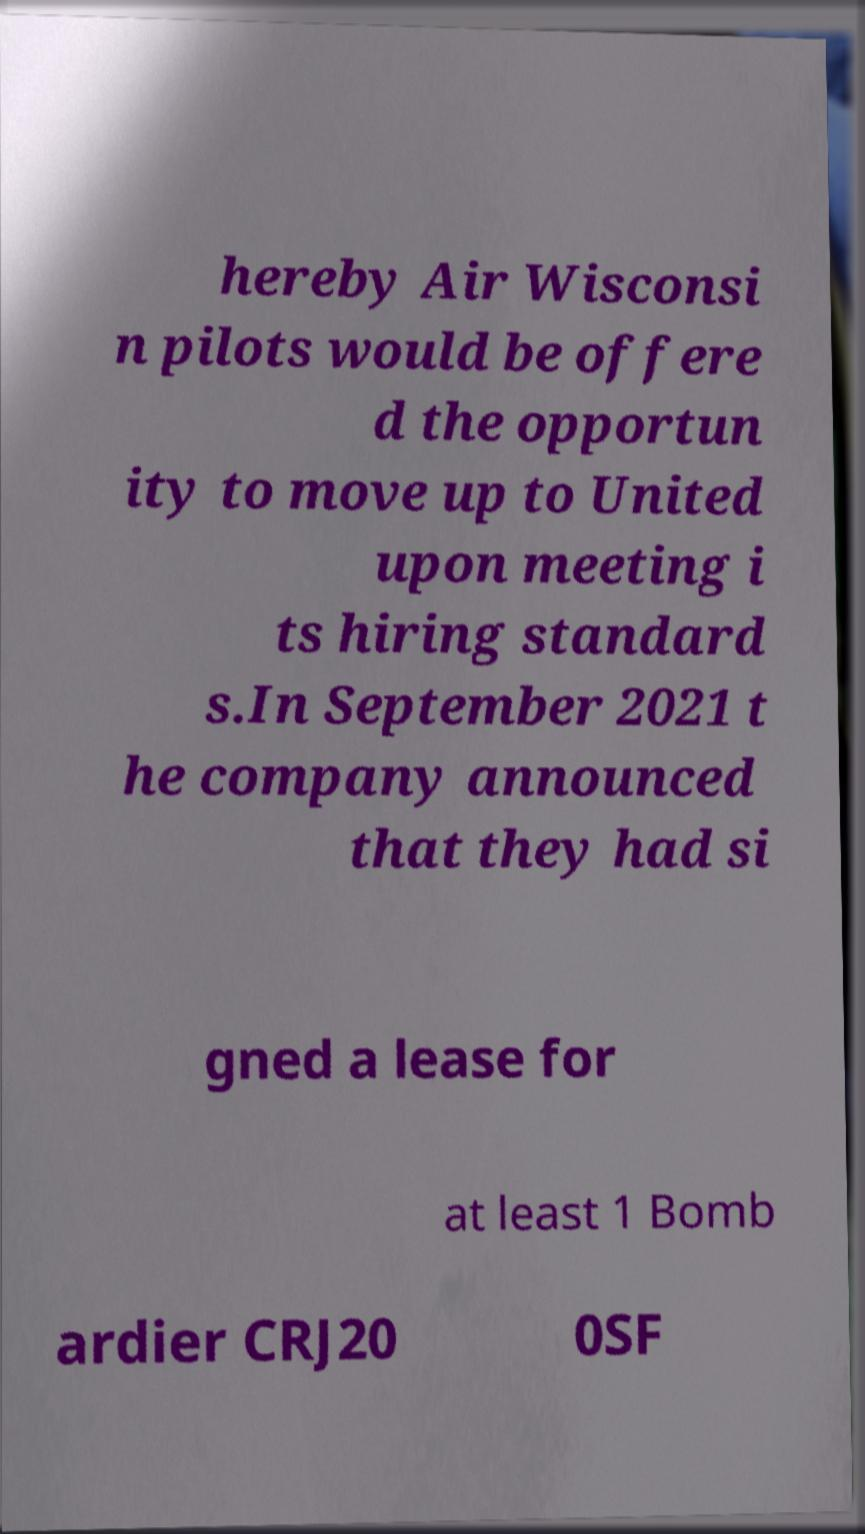What messages or text are displayed in this image? I need them in a readable, typed format. hereby Air Wisconsi n pilots would be offere d the opportun ity to move up to United upon meeting i ts hiring standard s.In September 2021 t he company announced that they had si gned a lease for at least 1 Bomb ardier CRJ20 0SF 